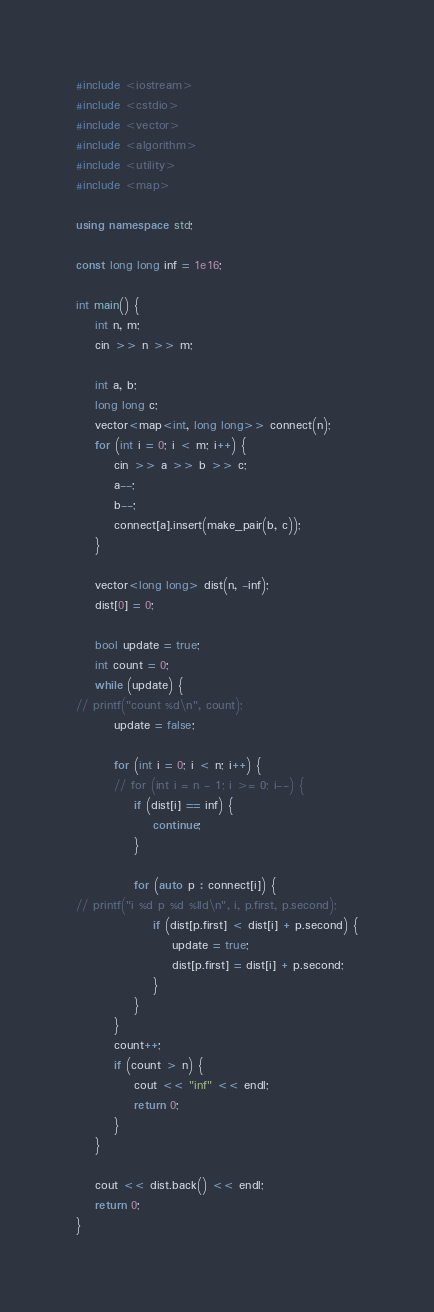Convert code to text. <code><loc_0><loc_0><loc_500><loc_500><_C++_>#include <iostream>
#include <cstdio>
#include <vector>
#include <algorithm>
#include <utility>
#include <map>

using namespace std;

const long long inf = 1e16;

int main() {
	int n, m;
	cin >> n >> m;

	int a, b;
	long long c;
	vector<map<int, long long>> connect(n);
	for (int i = 0; i < m; i++) {
		cin >> a >> b >> c;
		a--;
		b--;
		connect[a].insert(make_pair(b, c));
	}

	vector<long long> dist(n, -inf);
	dist[0] = 0;

	bool update = true;
	int count = 0;
	while (update) {
// printf("count %d\n", count);
		update = false;

		for (int i = 0; i < n; i++) {
		// for (int i = n - 1; i >= 0; i--) {
			if (dist[i] == inf) {
				continue;
			}

			for (auto p : connect[i]) {
// printf("i %d p %d %lld\n", i, p.first, p.second);
				if (dist[p.first] < dist[i] + p.second) {
					update = true;
					dist[p.first] = dist[i] + p.second;
				}
			}
		}
		count++;
		if (count > n) {
			cout << "inf" << endl;
			return 0;
		}
	}

	cout << dist.back() << endl;
	return 0;
}
</code> 